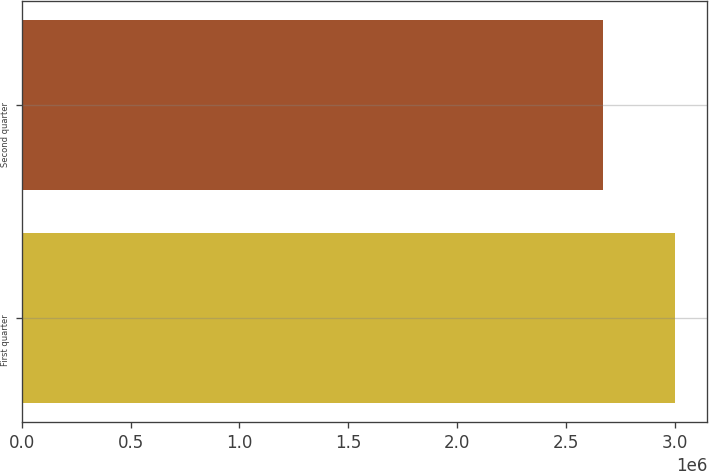Convert chart to OTSL. <chart><loc_0><loc_0><loc_500><loc_500><bar_chart><fcel>First quarter<fcel>Second quarter<nl><fcel>3e+06<fcel>2.6692e+06<nl></chart> 